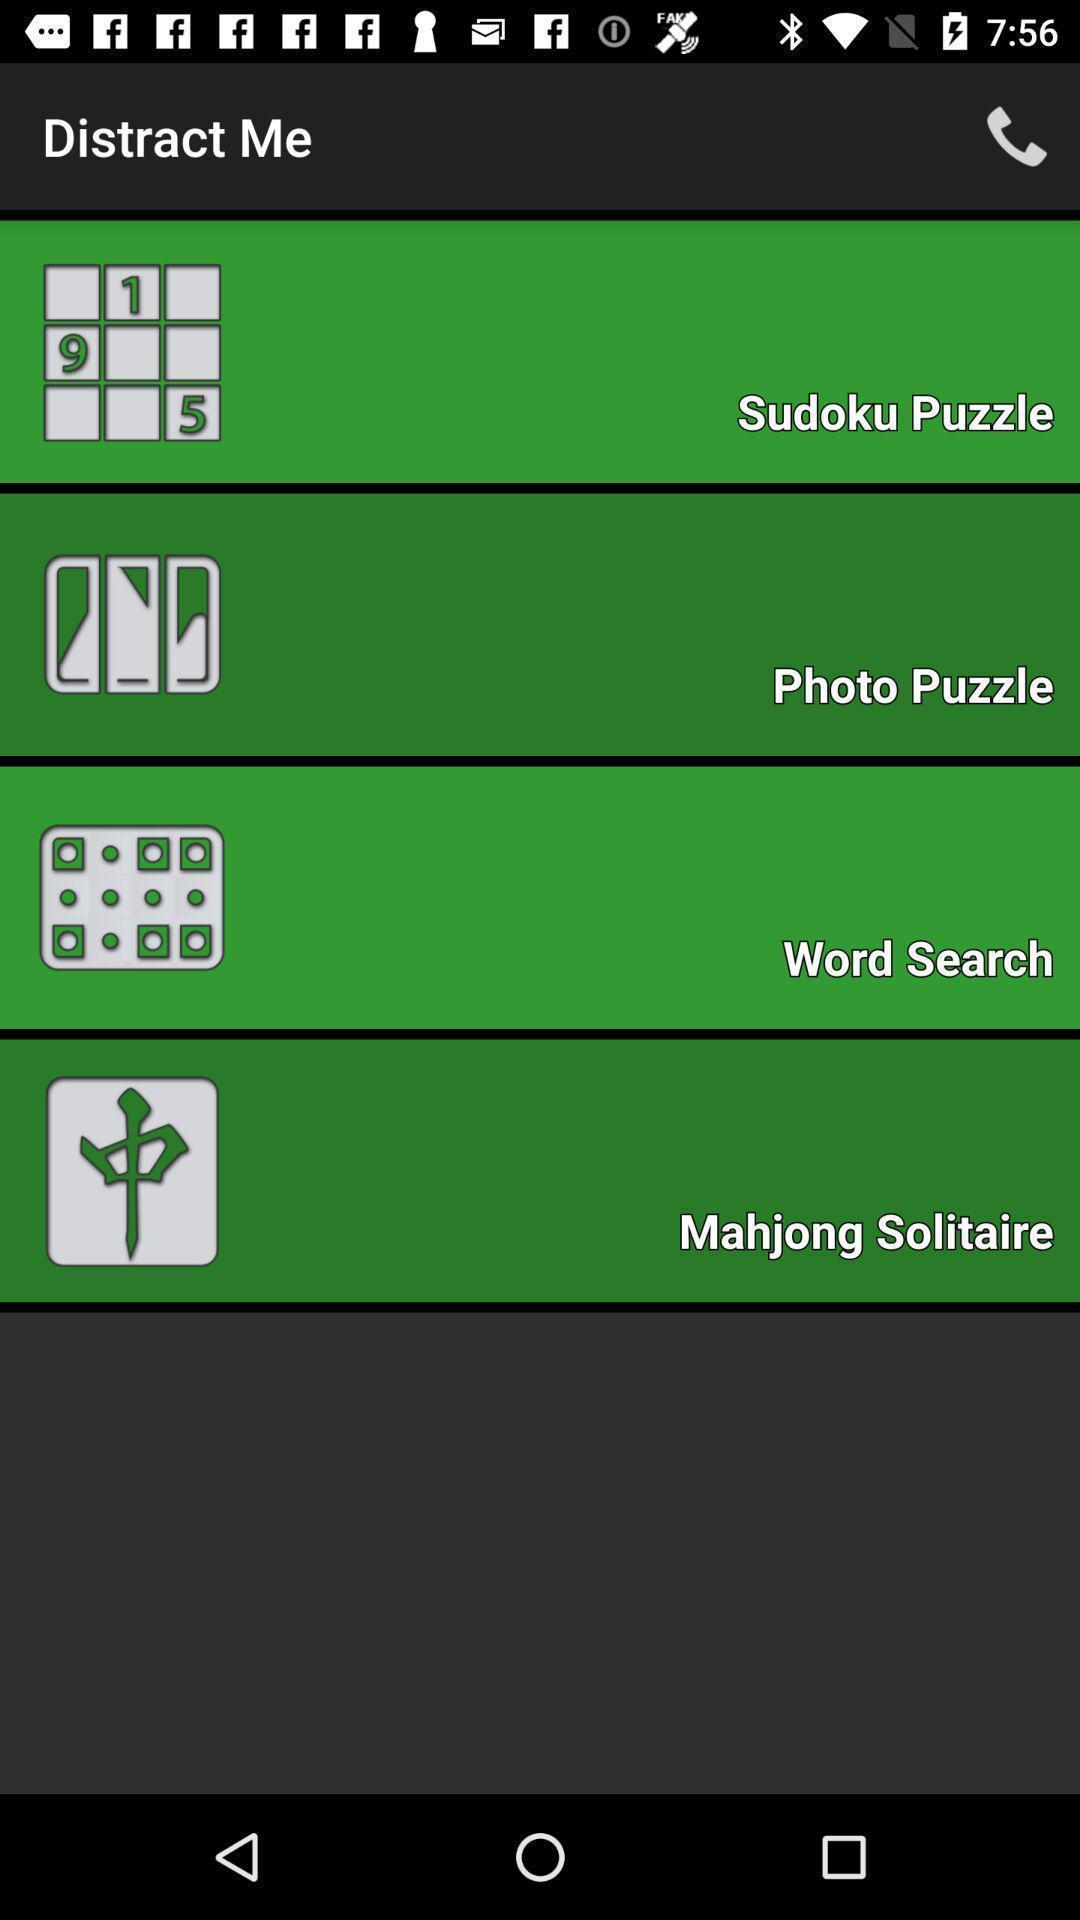Give me a narrative description of this picture. Various games page in a gaming app. 